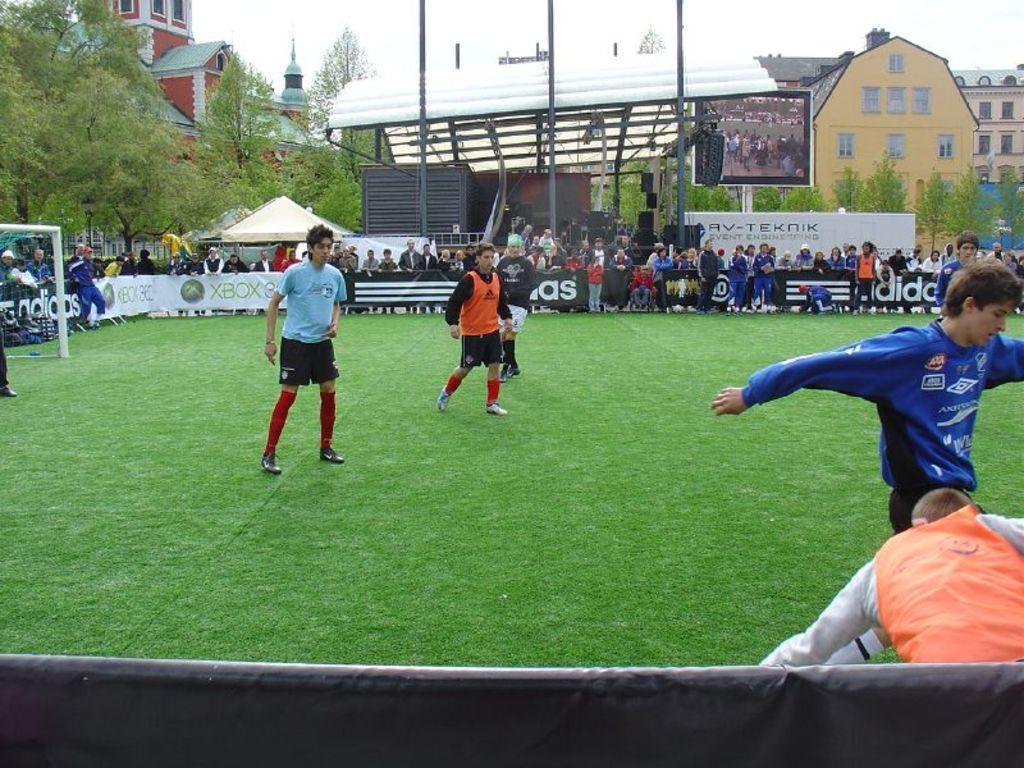Describe this image in one or two sentences. In this picture we can see there are groups of people. On the left side of the image, there is a football goal. Behind the people, there are boards, poles, trees, buildings, a screen and the sky. 